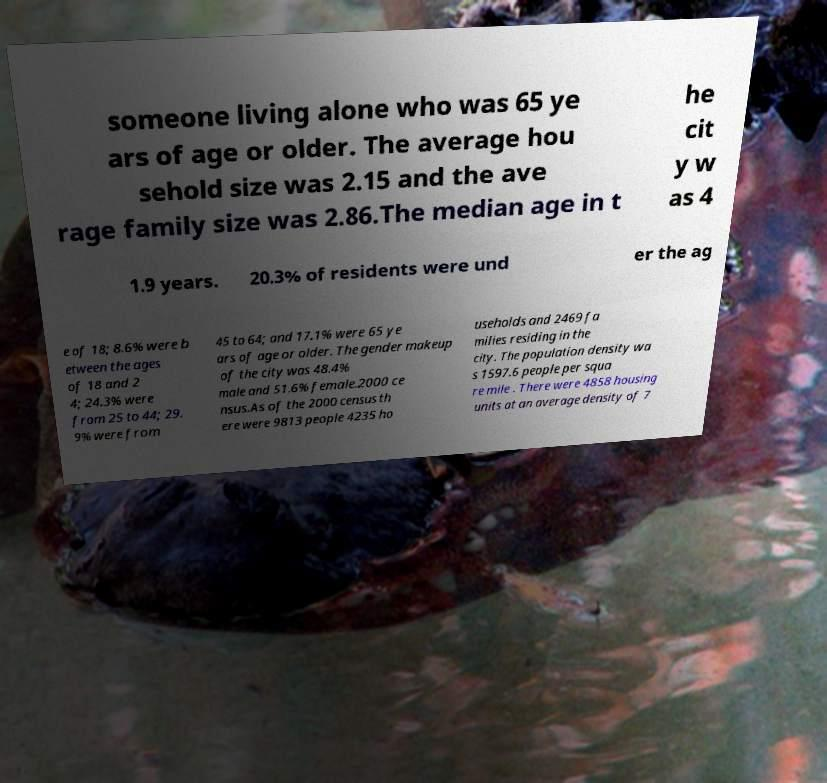Could you assist in decoding the text presented in this image and type it out clearly? someone living alone who was 65 ye ars of age or older. The average hou sehold size was 2.15 and the ave rage family size was 2.86.The median age in t he cit y w as 4 1.9 years. 20.3% of residents were und er the ag e of 18; 8.6% were b etween the ages of 18 and 2 4; 24.3% were from 25 to 44; 29. 9% were from 45 to 64; and 17.1% were 65 ye ars of age or older. The gender makeup of the city was 48.4% male and 51.6% female.2000 ce nsus.As of the 2000 census th ere were 9813 people 4235 ho useholds and 2469 fa milies residing in the city. The population density wa s 1597.6 people per squa re mile . There were 4858 housing units at an average density of 7 